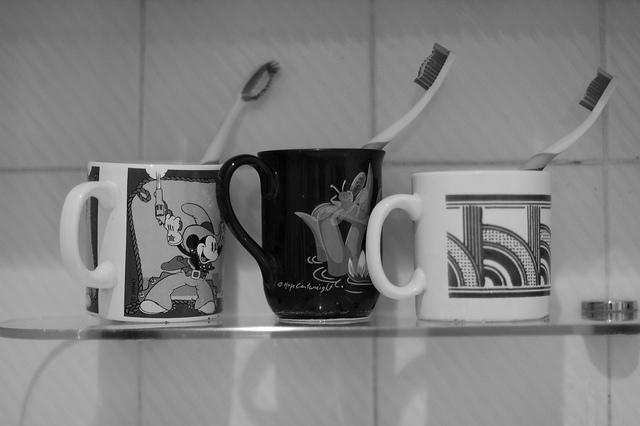How many people live here?
Give a very brief answer. 3. How many cups are there?
Give a very brief answer. 3. How many toothbrushes can you see?
Give a very brief answer. 2. How many people are in this picture?
Give a very brief answer. 0. 